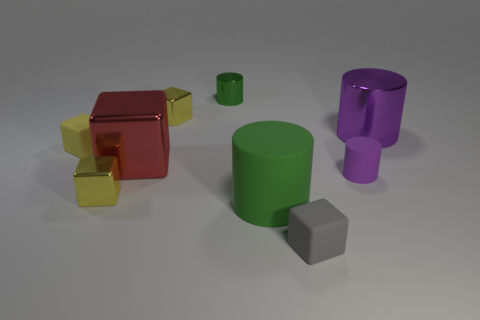Subtract all large metal cylinders. How many cylinders are left? 3 Subtract all green cylinders. How many cylinders are left? 2 Subtract 3 blocks. How many blocks are left? 2 Subtract all yellow balls. How many brown cylinders are left? 0 Subtract all tiny purple objects. Subtract all tiny green objects. How many objects are left? 7 Add 6 green rubber things. How many green rubber things are left? 7 Add 3 big gray objects. How many big gray objects exist? 3 Subtract 0 gray cylinders. How many objects are left? 9 Subtract all blocks. How many objects are left? 4 Subtract all gray cylinders. Subtract all purple spheres. How many cylinders are left? 4 